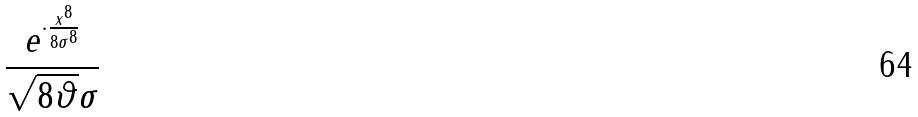Convert formula to latex. <formula><loc_0><loc_0><loc_500><loc_500>\frac { e ^ { \cdot \frac { x ^ { 8 } } { 8 \sigma ^ { 8 } } } } { \sqrt { 8 \vartheta } \sigma }</formula> 